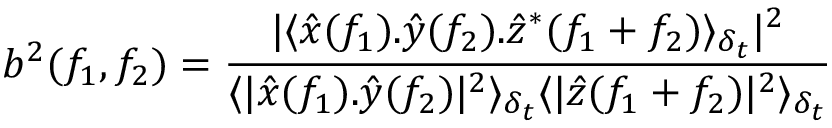Convert formula to latex. <formula><loc_0><loc_0><loc_500><loc_500>b ^ { 2 } ( f _ { 1 } , f _ { 2 } ) = \frac { | \langle \hat { x } ( f _ { 1 } ) . \hat { y } ( f _ { 2 } ) . \hat { z } ^ { * } ( f _ { 1 } + f _ { 2 } ) \rangle _ { \delta _ { t } } | ^ { 2 } } { \langle | \hat { x } ( f _ { 1 } ) . \hat { y } ( f _ { 2 } ) | ^ { 2 } \rangle _ { \delta _ { t } } \langle | \hat { z } ( f _ { 1 } + f _ { 2 } ) | ^ { 2 } \rangle _ { \delta _ { t } } }</formula> 